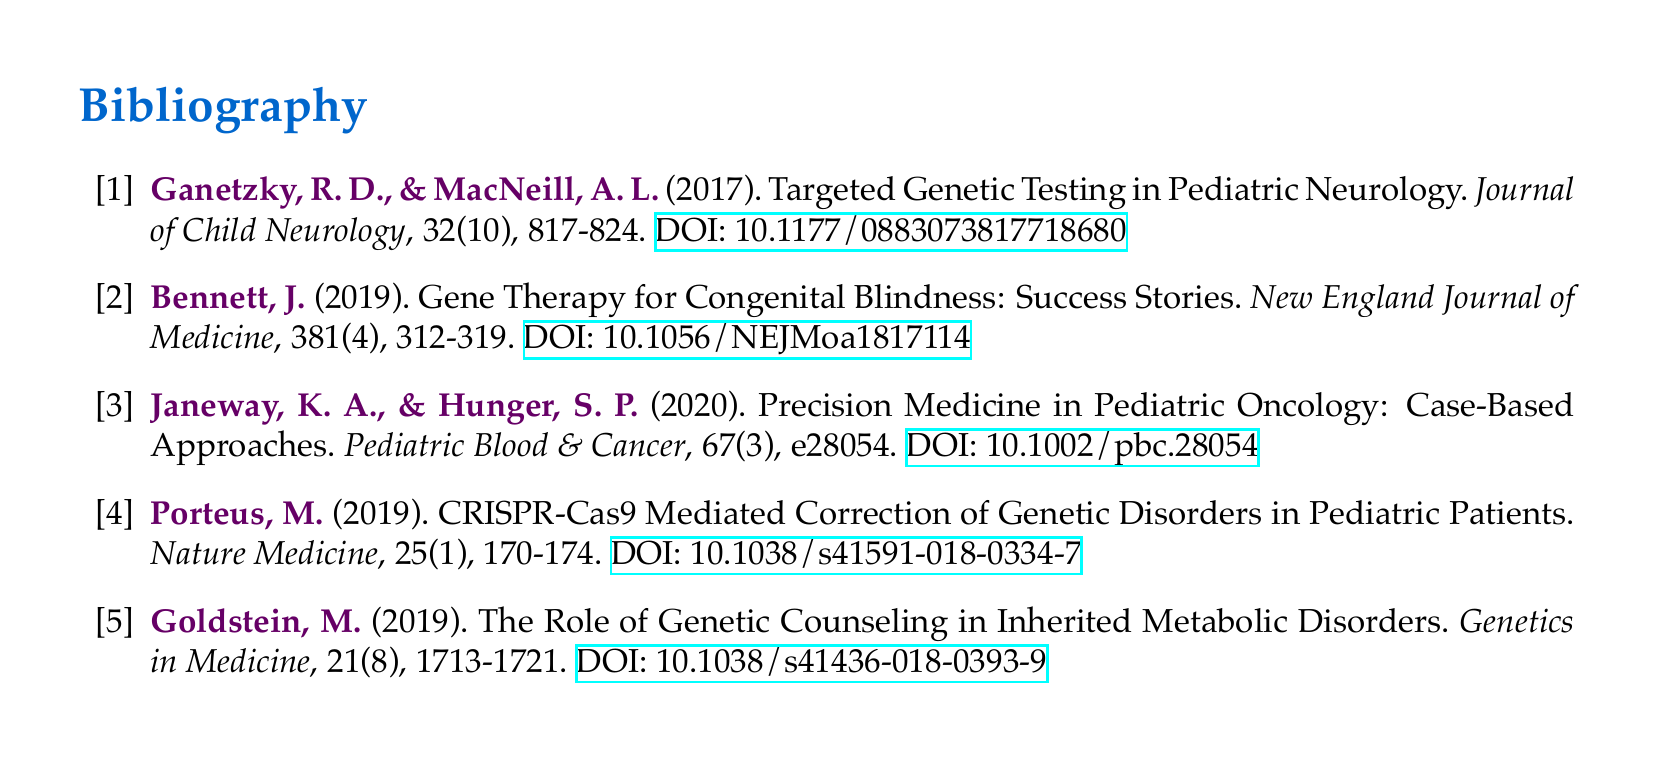What is the title of the first cited paper? The first cited paper is titled "Targeted Genetic Testing in Pediatric Neurology."
Answer: Targeted Genetic Testing in Pediatric Neurology Who are the authors of the paper published in 2019 about gene therapy? The authors of the 2019 paper on gene therapy are Bennett, J.
Answer: Bennett, J What journal published Porteus's 2019 article? The journal that published Porteus's article in 2019 is "Nature Medicine."
Answer: Nature Medicine What volume and issue number is Janeway's paper in? Janeway's paper is in volume 67, issue 3 of the journal.
Answer: 67(3) How many pages long is the article about genetic counseling? The article about genetic counseling is 8 pages long, from 1713 to 1721.
Answer: 1713-1721 Which genetic intervention is highlighted in Porteus's 2019 paper? Porteus's 2019 paper highlights CRISPR-Cas9 mediated correction.
Answer: CRISPR-Cas9 What year was the paper on precision medicine published? The paper on precision medicine was published in the year 2020.
Answer: 2020 What is the doi for the article discussing gene therapy for congenital blindness? The doi for the article is "10.1056/NEJMoa1817114."
Answer: 10.1056/NEJMoa1817114 In what area does the author Ganetzky focus his research? Ganetzky focuses his research on pediatric neurology.
Answer: pediatric neurology 